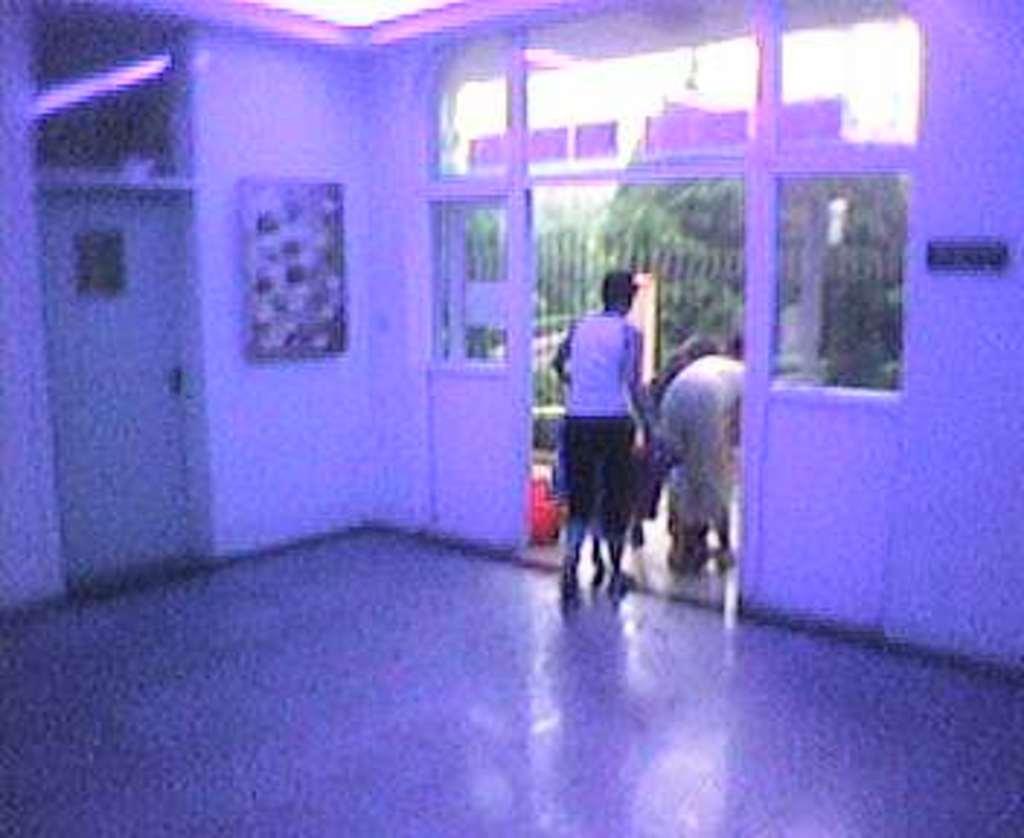Could you give a brief overview of what you see in this image? In this image I can see the inside of a room and in the middle of this picture I see few people and I see that this image is blurred and I see the floor in front. 